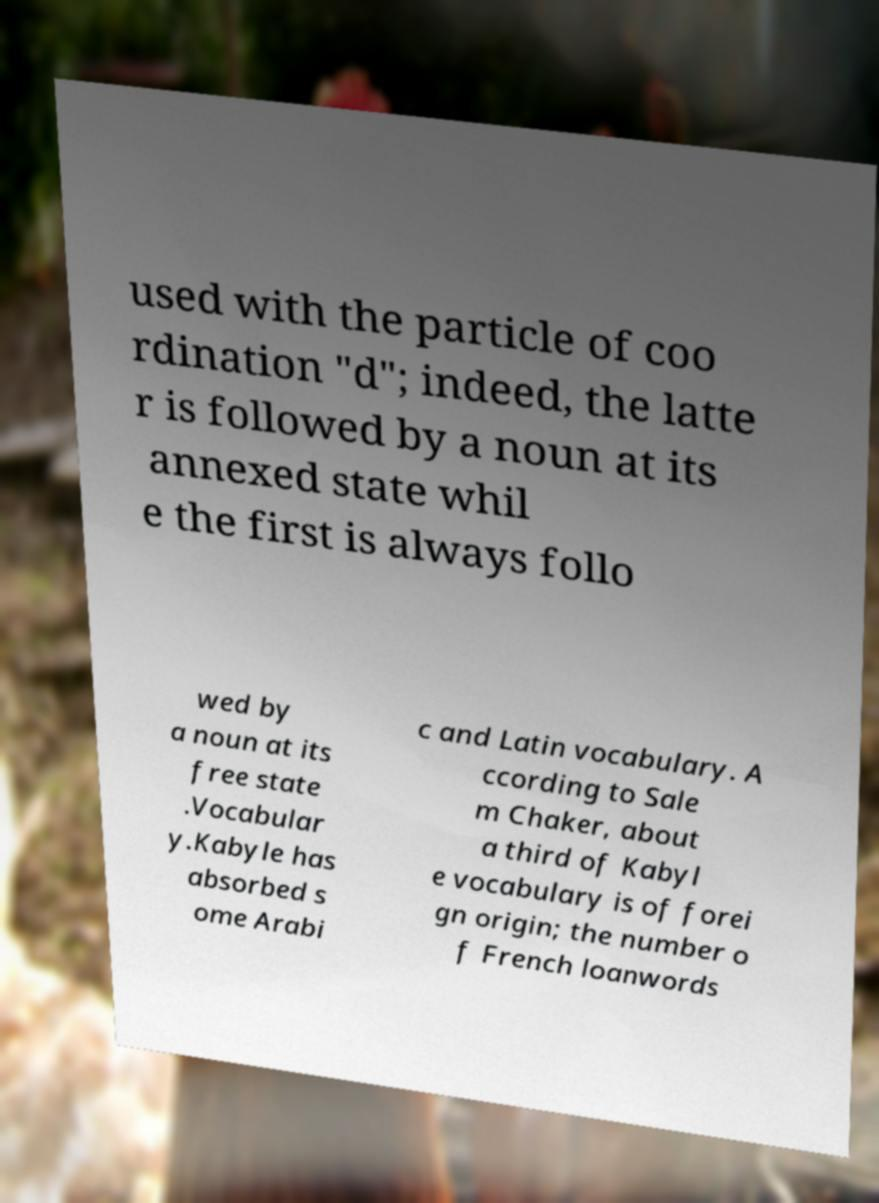Can you accurately transcribe the text from the provided image for me? used with the particle of coo rdination "d"; indeed, the latte r is followed by a noun at its annexed state whil e the first is always follo wed by a noun at its free state .Vocabular y.Kabyle has absorbed s ome Arabi c and Latin vocabulary. A ccording to Sale m Chaker, about a third of Kabyl e vocabulary is of forei gn origin; the number o f French loanwords 